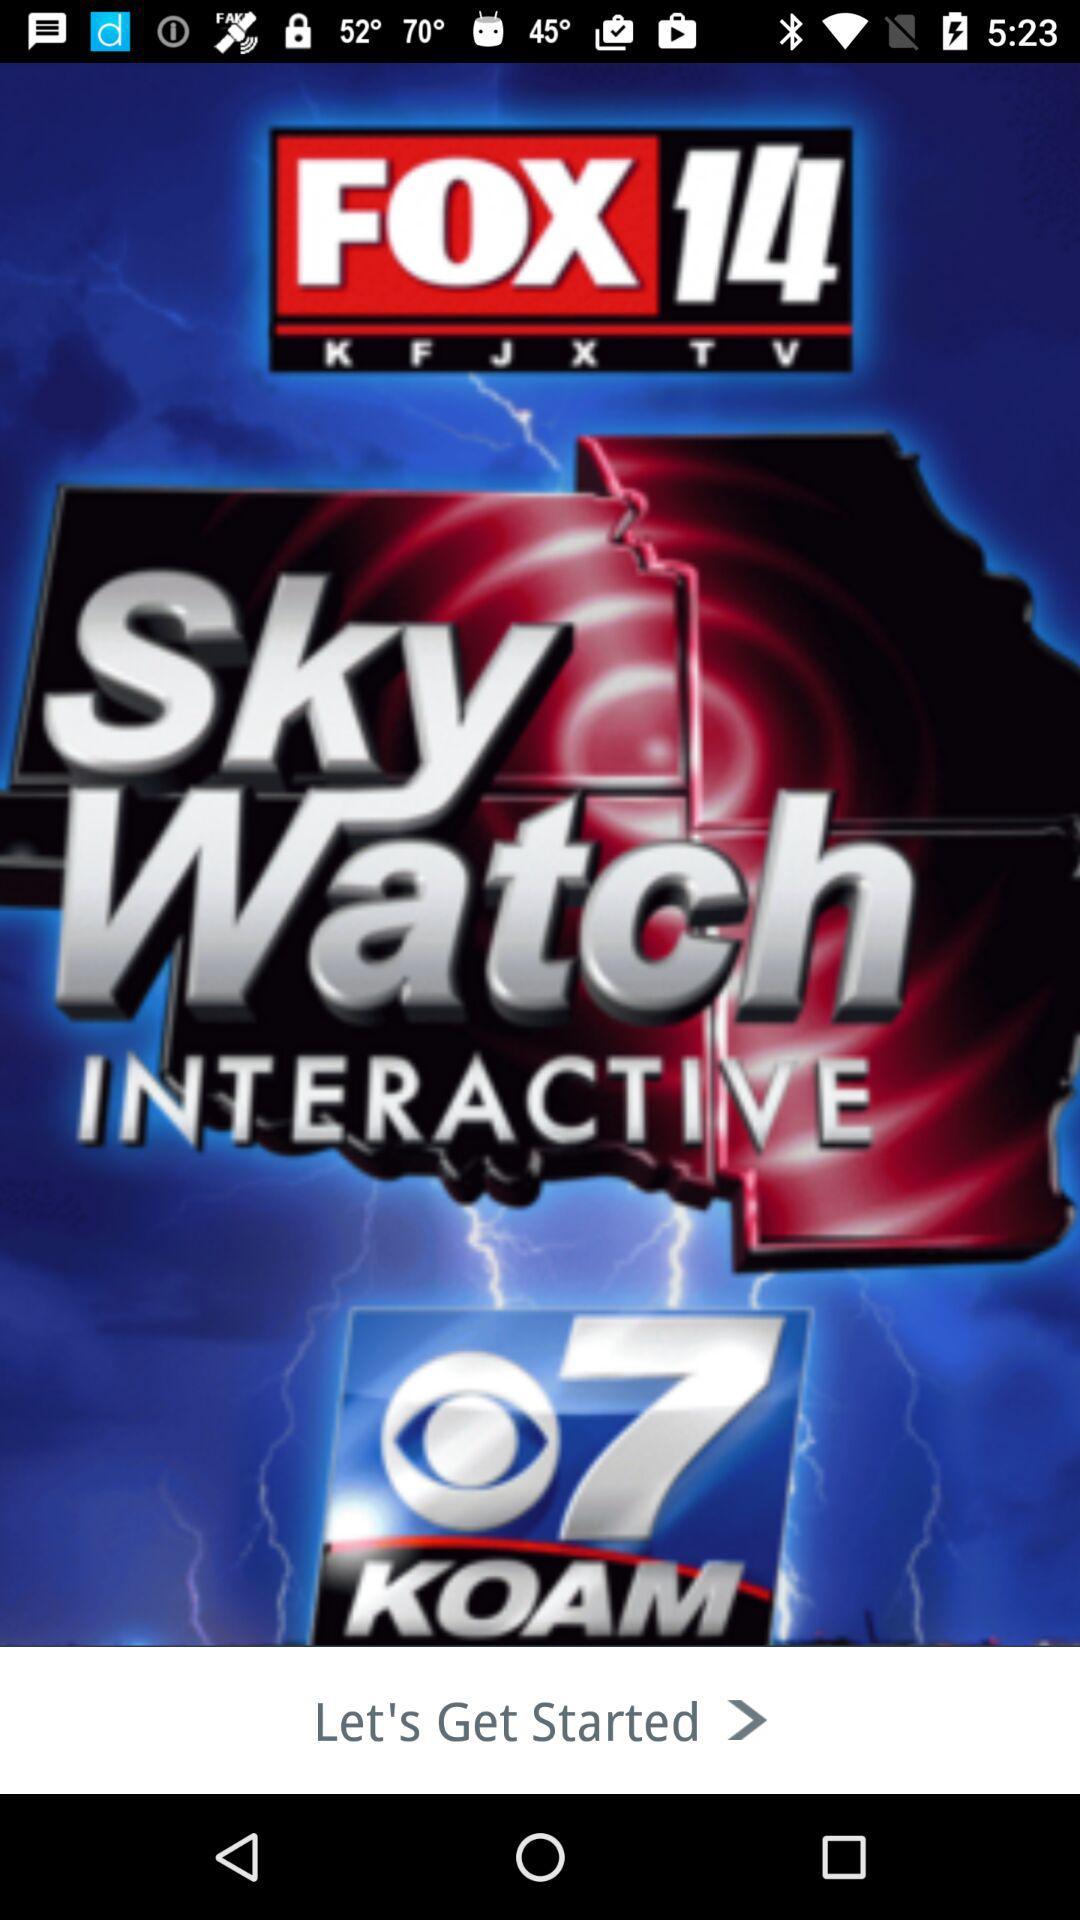Who is this application powered by?
When the provided information is insufficient, respond with <no answer>. <no answer> 